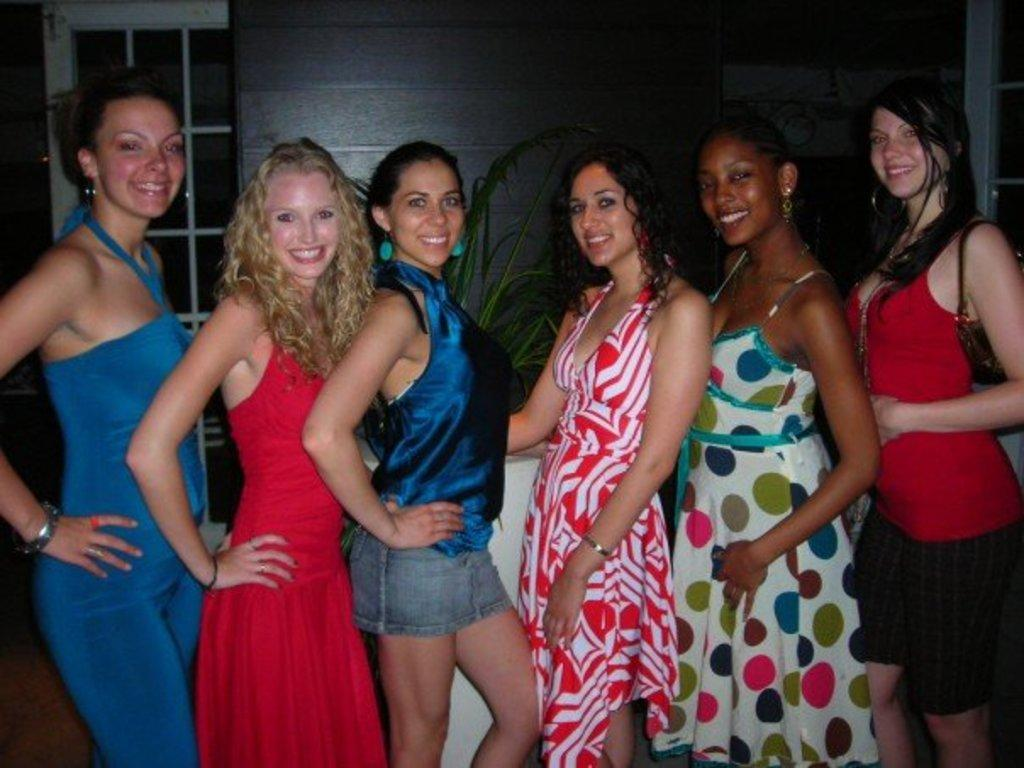What is happening in the foreground of the image? There are women standing in the foreground of the image, and they are posing for the camera. What can be seen in the background of the image? There is a wall, plants, a door, and a window in the background of the image. What type of rod is being used to stir the celery in the image? There is no celery or rod present in the image. How many stamps are visible on the door in the image? There are no stamps visible on the door in the image. 